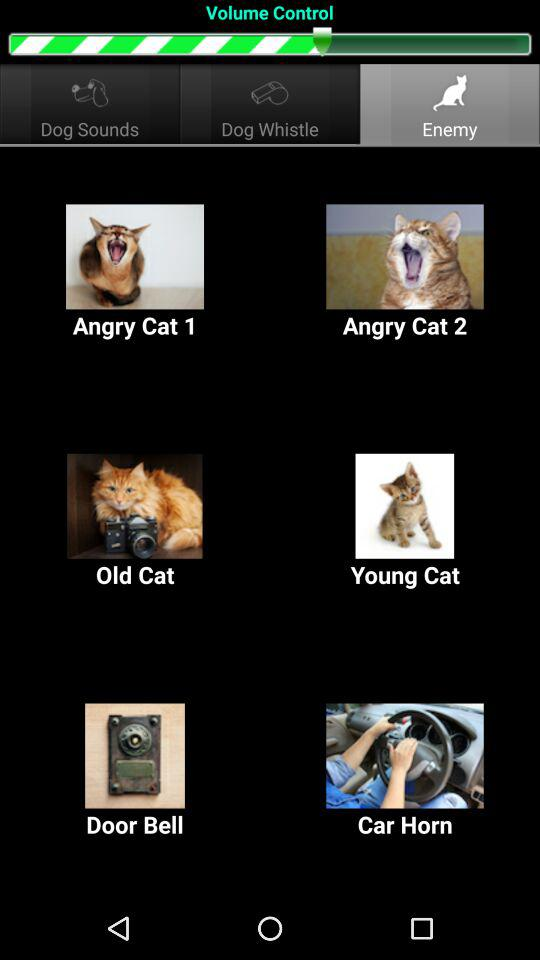Which tab has been selected? The selected tab is "Enemy". 